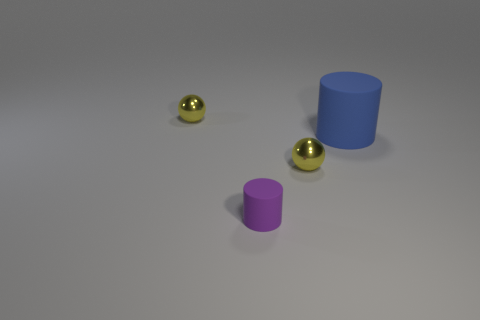Add 4 large green balls. How many objects exist? 8 Add 4 large blue cylinders. How many large blue cylinders exist? 5 Subtract 0 brown cylinders. How many objects are left? 4 Subtract all tiny cylinders. Subtract all small yellow things. How many objects are left? 1 Add 4 small purple cylinders. How many small purple cylinders are left? 5 